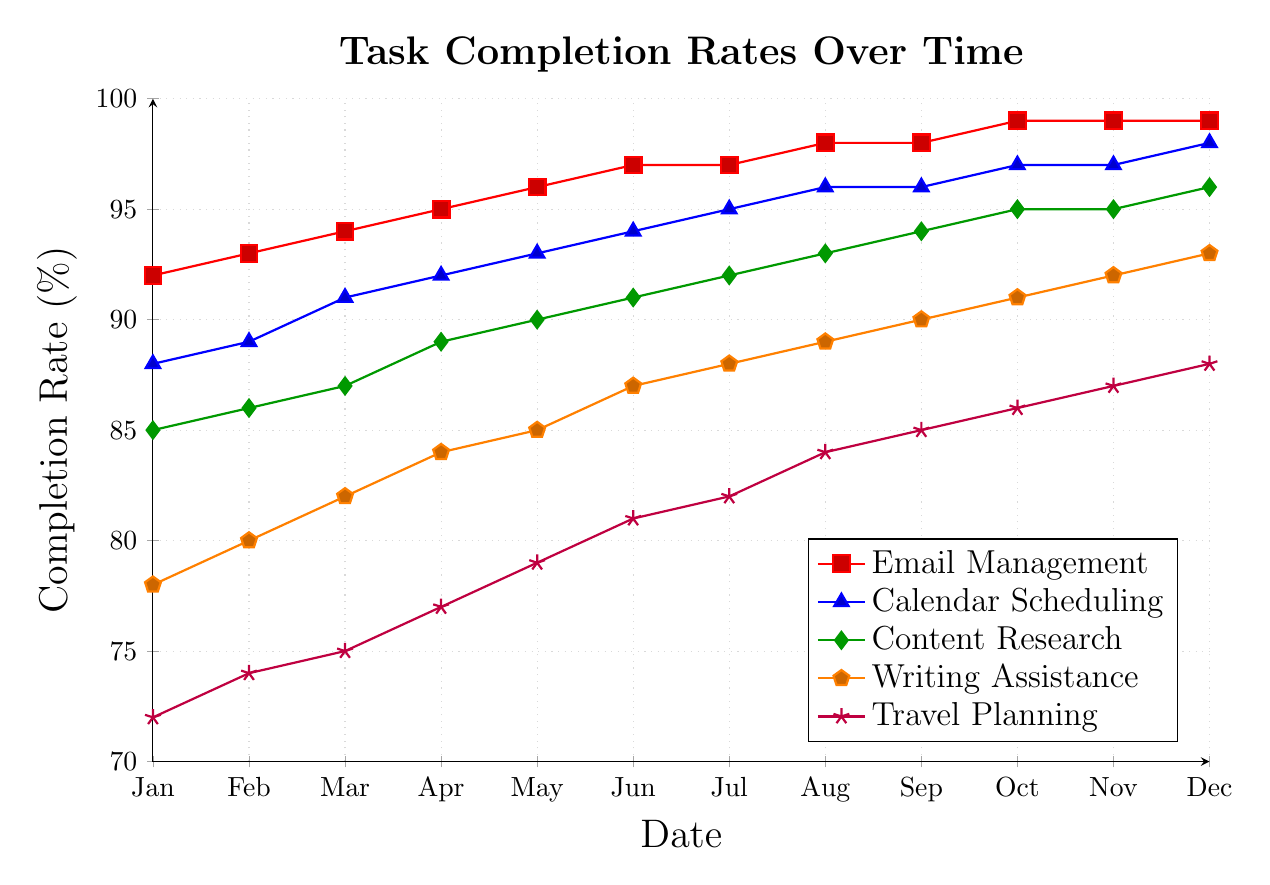What's the highest completion rate for Email Management? The highest completion rate for Email Management can be found by looking at the peak value of the red line. The peak value occurs in October, November, and December at a rate of 99%.
Answer: 99% How does the completion rate of Writing Assistance in January compare to December? To compare the completion rates, look at the values for Writing Assistance in January and December. In January, the value is 78%, and in December, it is 93%.
Answer: December is 15% higher than January Which task has the lowest completion rate in January? By checking the data points for January, we can see that Travel Planning has the lowest completion rate, marked by the purple line at 72%.
Answer: Travel Planning What is the average completion rate for Calendar Scheduling over the year? To calculate the average completion rate for Calendar Scheduling, sum the monthly values and divide by 12: (88 + 89 + 91 + 92 + 93 + 94 + 95 + 96 + 96 + 97 + 97 + 98) / 12 = 94.
Answer: 94% How much did the completion rate for Content Research increase from March to September? To find the increase, subtract the completion rate of Content Research in March from that in September. The rates are 87% in March and 94% in September: 94% - 87% = 7%.
Answer: 7% What is the trend of the completion rate for Travel Planning throughout the year? To observe the trend for Travel Planning (purple line), note the continuous increase from 72% in January to 88% in December.
Answer: Increasing Which task had the steepest increase in its completion rate from January to December? To determine the steepest increase, calculate the differences for each task from January to December. Travel Planning increased by 16% (72% to 88%), which is the steepest compared to other tasks.
Answer: Travel Planning In which month does Content Research achieve a 90% completion rate? To find the month where Content Research (green line) reaches 90%, check the data points. It achieves 90% in May.
Answer: May Between August and September, which task showed no change in its completion rate? Comparing the values for August and September, the tasks that showed no change are Calendar Scheduling (both 96%) and Email Management (both 98%).
Answer: Calendar Scheduling and Email Management What is the difference in completion rates between Travel Planning and Email Management in December? The completion rate for Travel Planning in December is 88%, and for Email Management, it is 99%. Subtracting the two values gives 99% - 88% = 11%.
Answer: 11% 